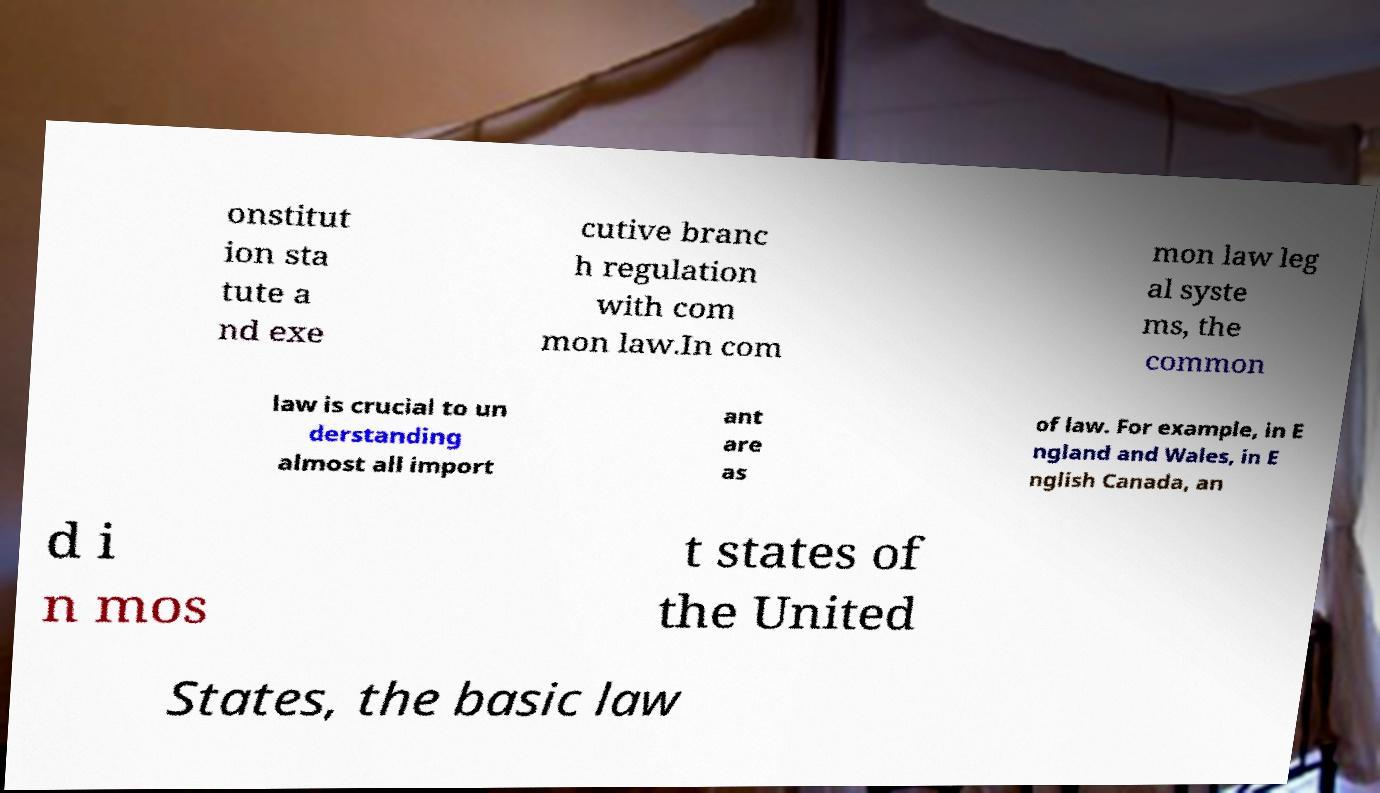I need the written content from this picture converted into text. Can you do that? onstitut ion sta tute a nd exe cutive branc h regulation with com mon law.In com mon law leg al syste ms, the common law is crucial to un derstanding almost all import ant are as of law. For example, in E ngland and Wales, in E nglish Canada, an d i n mos t states of the United States, the basic law 